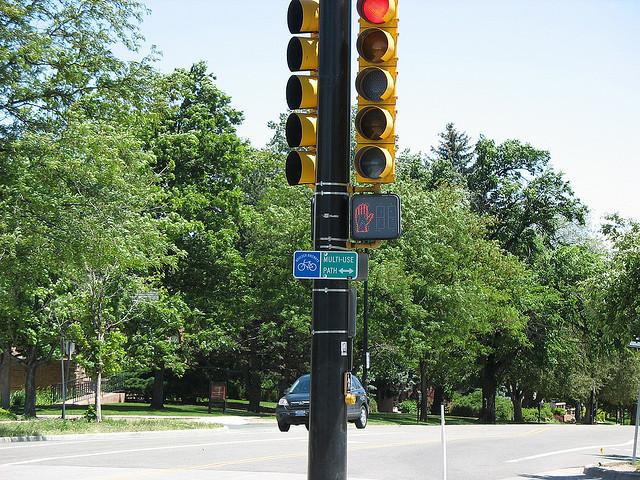Is there a lot of traffic on this street?
Give a very brief answer. No. Is this a summer day?
Answer briefly. Yes. Is it safe to use the crosswalk?
Answer briefly. No. 